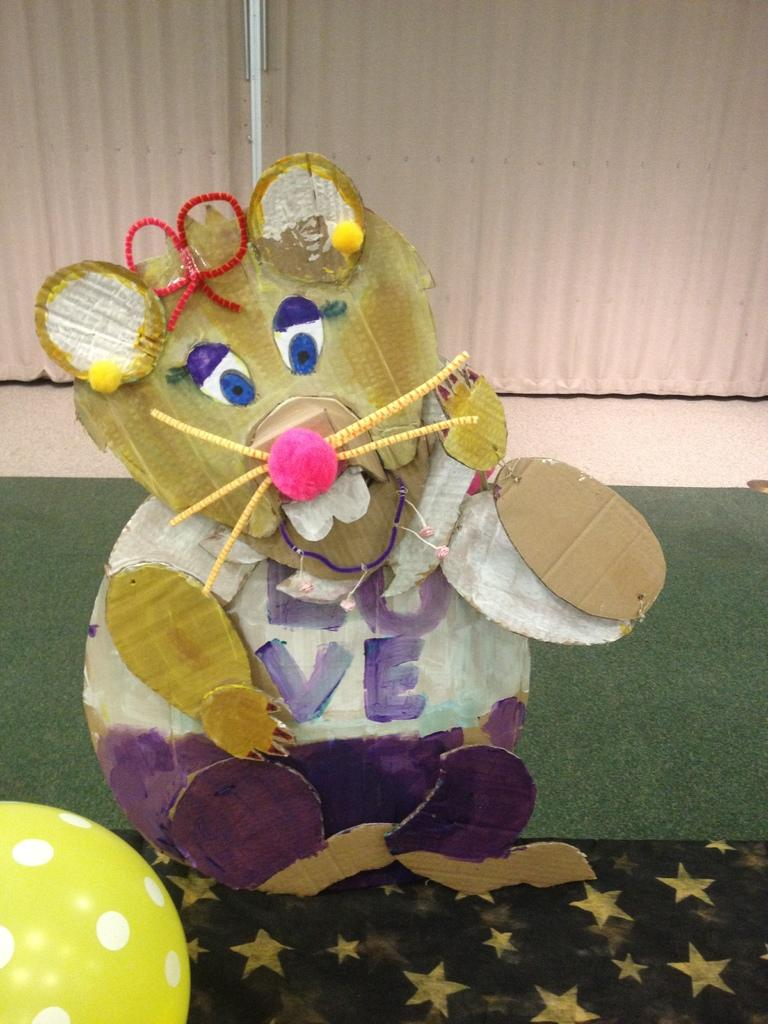What object can be seen on the path in the image? There is a toy on the path in the image. What is in front of the toy on the path? There is a balloon and a cloth in front of the toy. What is behind the toy in the image? There is a wall behind the toy. Can you describe the feature in the wall? It appears to be a door in the wall. How is the chalk distributed on the toy in the image? There is no chalk present in the image, so it cannot be distributed on the toy. 